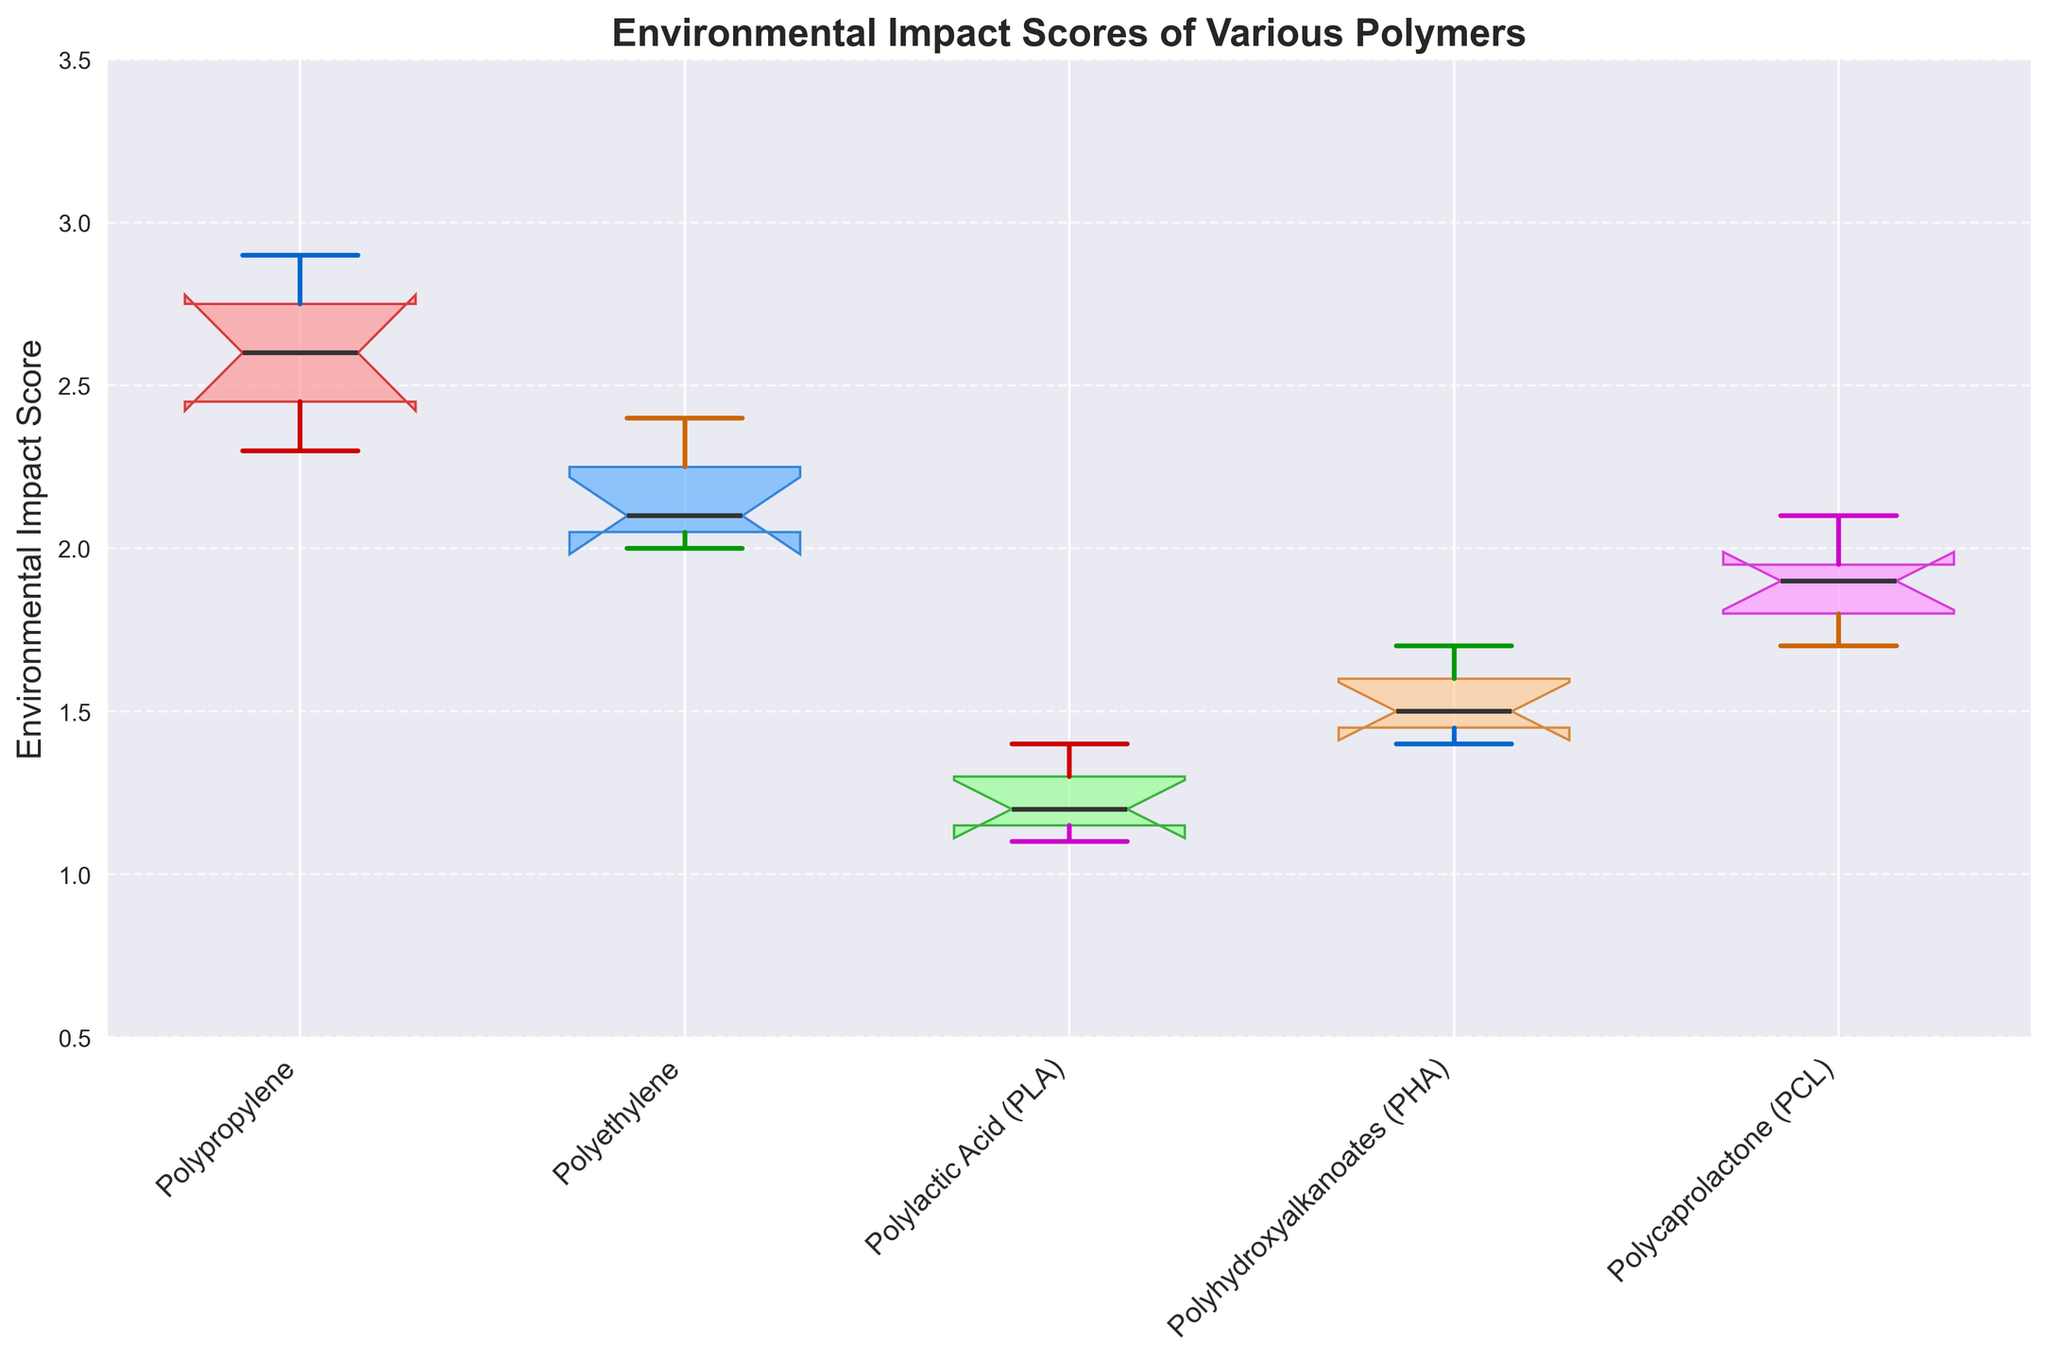Which polymer has the lowest median impact score? The median impact score is indicated by the bold line inside each box. The polymer with the lowest position of this line is Polylactic Acid (PLA).
Answer: Polylactic Acid (PLA) What is the range of the environmental impact scores for Polypropylene? The range can be calculated by subtracting the minimum value at the lower whisker end from the maximum value at the upper whisker end. For Polypropylene, the range is from 2.3 to 2.9.
Answer: 0.6 Which biodegradable polymer shows the greatest variation in its environmental impact scores? The variation in scores can be identified by looking at the length of the box and whiskers. Polycaprolactone (PCL) has the largest variation with scores ranging from 1.7 to 2.1.
Answer: Polycaprolactone (PCL) Between Polyethylene and Polyhydroxyalkanoates (PHA), which polymer has a higher environmental impact score range? By comparing the lengths of the whiskers and boxes of both polymers, Polyethylene has a range from 2.0 to 2.4, and PHA has a range from 1.4 to 1.7. Therefore, Polyethylene has a higher range.
Answer: Polyethylene What is the median environmental impact score for Polyhydroxyalkanoates (PHA)? The median score is indicated by the bold line inside the box for PHA, which is at 1.5.
Answer: 1.5 Which polymers are below the environmental impact score of 1.8 within their notches? The notches in box plots represent the confidence interval around the median. PLA, PHA, and PCL are the polymers with notches below the score of 1.8.
Answer: PLA, PHA, PCL Are any of the polymers' notches overlapping, and what does it imply? By observing the plot, none of the polymers' notches overlap, meaning their medians are significantly different from each other at a 95% confidence level.
Answer: No, significant difference Which polymer has the smallest interquartile range (IQR) for its environmental impact scores? The IQR is the difference between the first quartile (bottom of the box) and the third quartile (top of the box). The polymer with the smallest height of the box is Polyhydroxyalkanoates (PHA).
Answer: Polyhydroxyalkanoates (PHA) What is the upper quartile value for Polypropylene? The upper quartile (75th percentile) is indicated by the top edge of the box for Polypropylene, which is at approximately 2.8.
Answer: 2.8 How do the environmental impact scores of the biodegradable polymers compare with those of the non-biodegradable polymers? By comparing the ranges and medians, biodegradable polymers (PLA, PHA, PCL) generally have lower impact scores and tighter ranges than non-biodegradable polymers (Polypropylene and Polyethylene).
Answer: Biodegradable polymers have lower scores and tighter ranges 